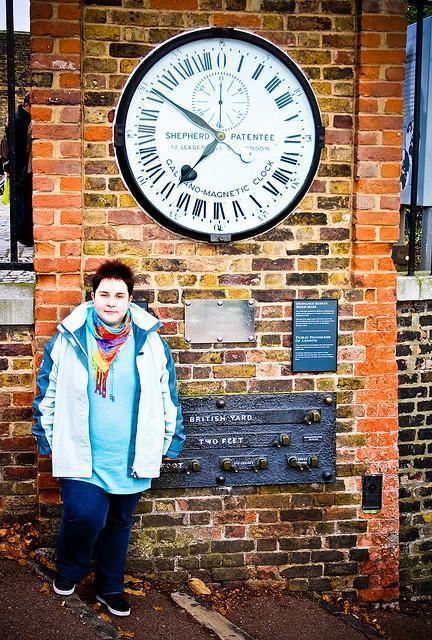How many people can be seen?
Give a very brief answer. 2. 